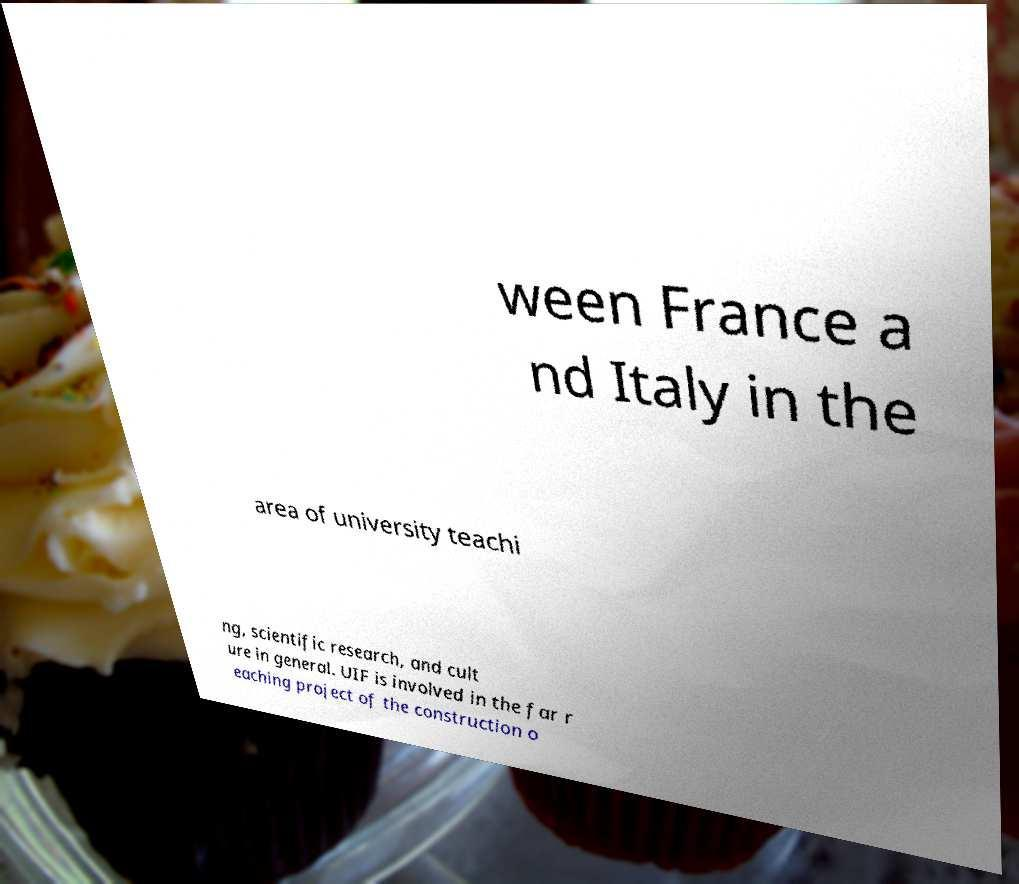There's text embedded in this image that I need extracted. Can you transcribe it verbatim? ween France a nd Italy in the area of university teachi ng, scientific research, and cult ure in general. UIF is involved in the far r eaching project of the construction o 